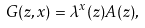<formula> <loc_0><loc_0><loc_500><loc_500>G ( z , x ) = \lambda ^ { x } ( z ) A ( z ) ,</formula> 